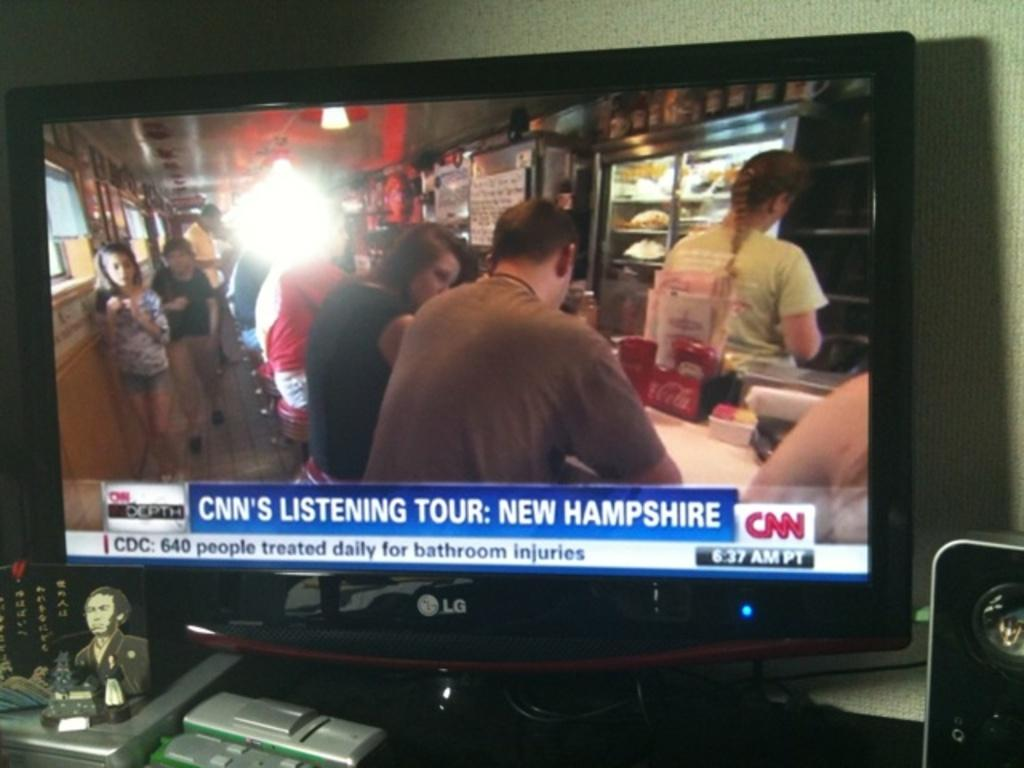<image>
Write a terse but informative summary of the picture. an LG flat screen tv with a CNN news snippit about new hampshire 